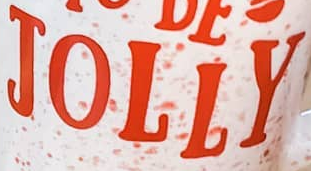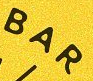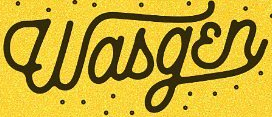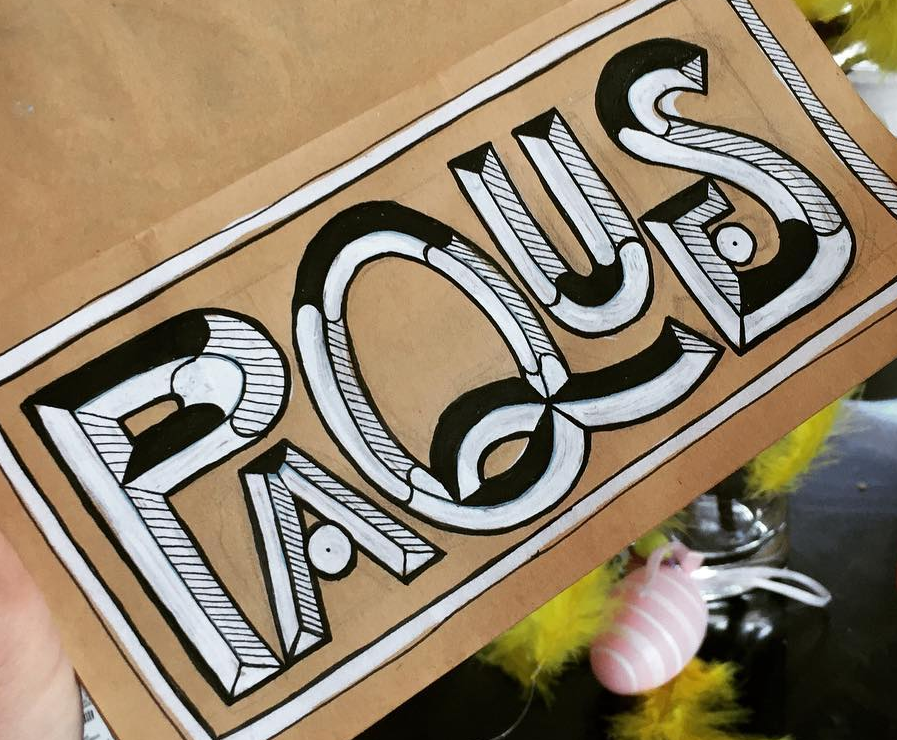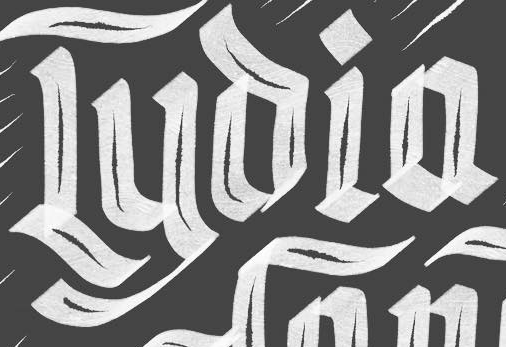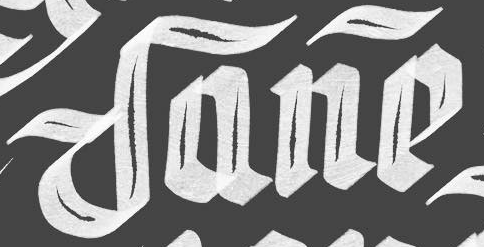What words are shown in these images in order, separated by a semicolon? JOLLY; BAR; Wasgɛn; PAQUES; Lyoia; Dane 